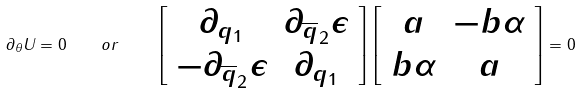Convert formula to latex. <formula><loc_0><loc_0><loc_500><loc_500>\partial _ { \theta } U = 0 \quad o r \quad \left [ \begin{array} { c c } \partial _ { { q } _ { 1 } } & \partial _ { \overline { q } _ { 2 } } \epsilon \\ - \partial _ { \overline { q } _ { 2 } } \epsilon & \partial _ { { q } _ { 1 } } \end{array} \right ] \left [ \begin{array} { c c } a & - b \alpha \\ b \alpha & a \end{array} \right ] = 0</formula> 